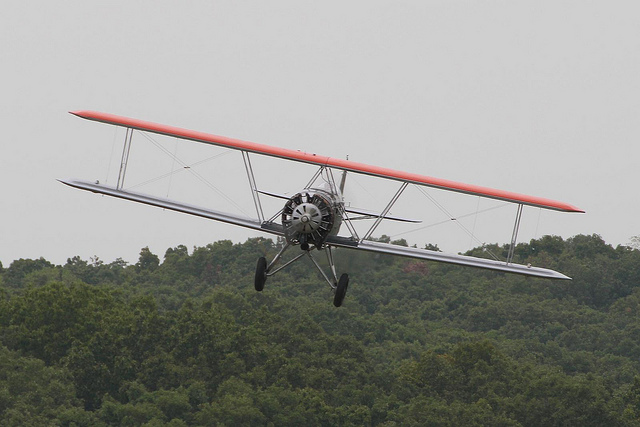What type of airplane is shown in this image?
Answer the question using a single word or phrase. Biplane 